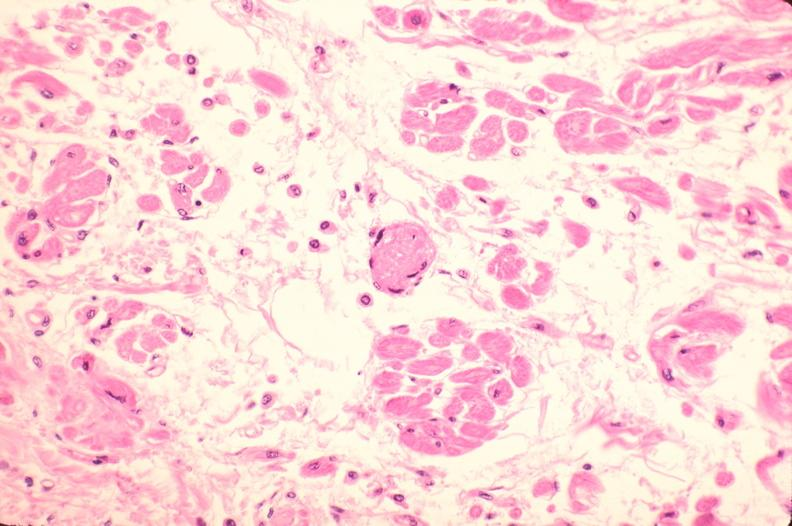s cardiovascular present?
Answer the question using a single word or phrase. Yes 